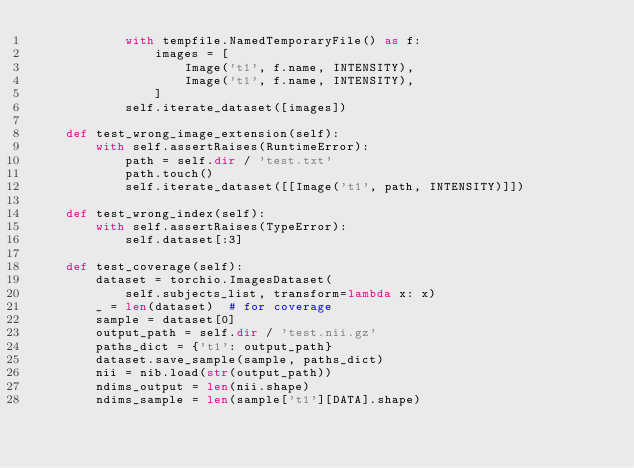Convert code to text. <code><loc_0><loc_0><loc_500><loc_500><_Python_>            with tempfile.NamedTemporaryFile() as f:
                images = [
                    Image('t1', f.name, INTENSITY),
                    Image('t1', f.name, INTENSITY),
                ]
            self.iterate_dataset([images])

    def test_wrong_image_extension(self):
        with self.assertRaises(RuntimeError):
            path = self.dir / 'test.txt'
            path.touch()
            self.iterate_dataset([[Image('t1', path, INTENSITY)]])

    def test_wrong_index(self):
        with self.assertRaises(TypeError):
            self.dataset[:3]

    def test_coverage(self):
        dataset = torchio.ImagesDataset(
            self.subjects_list, transform=lambda x: x)
        _ = len(dataset)  # for coverage
        sample = dataset[0]
        output_path = self.dir / 'test.nii.gz'
        paths_dict = {'t1': output_path}
        dataset.save_sample(sample, paths_dict)
        nii = nib.load(str(output_path))
        ndims_output = len(nii.shape)
        ndims_sample = len(sample['t1'][DATA].shape)</code> 